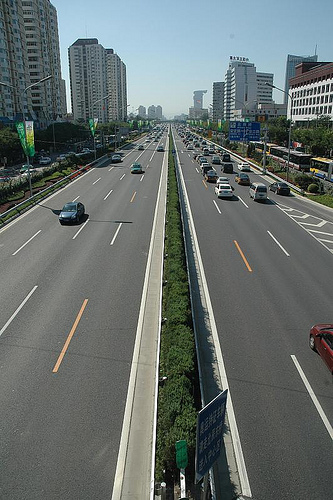<image>
Is the car in front of the car? Yes. The car is positioned in front of the car, appearing closer to the camera viewpoint. 